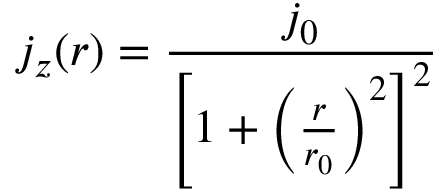<formula> <loc_0><loc_0><loc_500><loc_500>j _ { z } ( r ) = \frac { j _ { 0 } } { \left [ 1 + \left ( \frac { r } { r _ { 0 } } \right ) ^ { 2 } \right ] ^ { 2 } }</formula> 